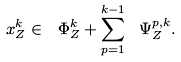<formula> <loc_0><loc_0><loc_500><loc_500>x _ { Z } ^ { k } \in \ \Phi _ { Z } ^ { k } + \sum _ { p = 1 } ^ { k - 1 } \ \Psi _ { Z } ^ { p , k } .</formula> 